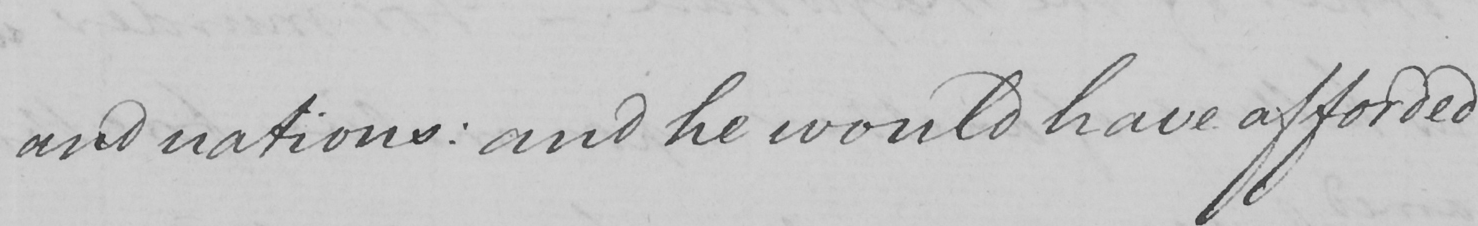What is written in this line of handwriting? and nations :  and he would have afforded 